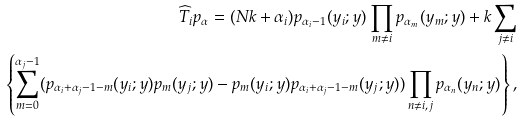<formula> <loc_0><loc_0><loc_500><loc_500>\widehat { T } _ { i } p _ { \alpha } = ( N k + \alpha _ { i } ) p _ { \alpha _ { i } - 1 } ( y _ { i } ; y ) \prod _ { m \neq i } p _ { \alpha _ { m } } ( y _ { m } ; y ) + k \sum _ { j \neq i } \\ \left \{ \sum _ { m = 0 } ^ { \alpha _ { j } - 1 } ( p _ { \alpha _ { i } + \alpha _ { j } - 1 - m } ( y _ { i } ; y ) p _ { m } ( y _ { j } ; y ) - p _ { m } ( y _ { i } ; y ) p _ { \alpha _ { i } + \alpha _ { j } - 1 - m } ( y _ { j } ; y ) ) \prod _ { n \neq i , j } p _ { \alpha _ { n } } ( y _ { n } ; y ) \right \} ,</formula> 